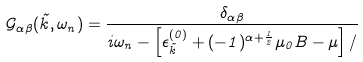Convert formula to latex. <formula><loc_0><loc_0><loc_500><loc_500>\mathcal { G } _ { \alpha \beta } ( \vec { k } , \omega _ { n } ) = \frac { \delta _ { \alpha \beta } } { i \omega _ { n } - \left [ \epsilon _ { \vec { k } } ^ { ( 0 ) } + ( - 1 ) ^ { \alpha + \frac { 1 } { 2 } } \mu _ { 0 } B - \mu \right ] / }</formula> 